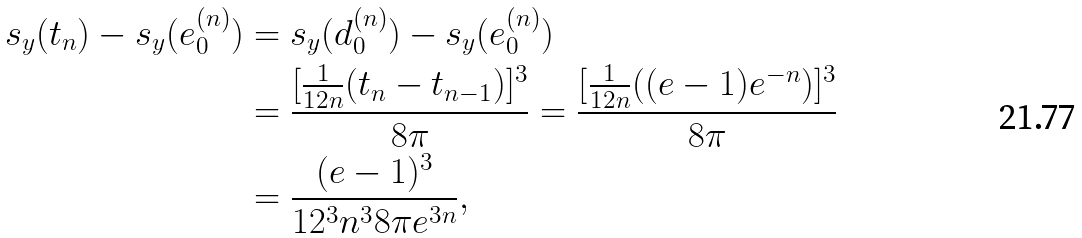<formula> <loc_0><loc_0><loc_500><loc_500>s _ { y } ( t _ { n } ) - s _ { y } ( e _ { 0 } ^ { ( n ) } ) & = s _ { y } ( d _ { 0 } ^ { ( n ) } ) - s _ { y } ( e _ { 0 } ^ { ( n ) } ) \\ & = \frac { [ \frac { 1 } { 1 2 n } ( t _ { n } - t _ { n - 1 } ) ] ^ { 3 } } { 8 \pi } = \frac { [ \frac { 1 } { 1 2 n } ( ( e - 1 ) e ^ { - n } ) ] ^ { 3 } } { 8 \pi } \\ & = \frac { ( e - 1 ) ^ { 3 } } { 1 2 ^ { 3 } n ^ { 3 } 8 \pi e ^ { 3 n } } ,</formula> 